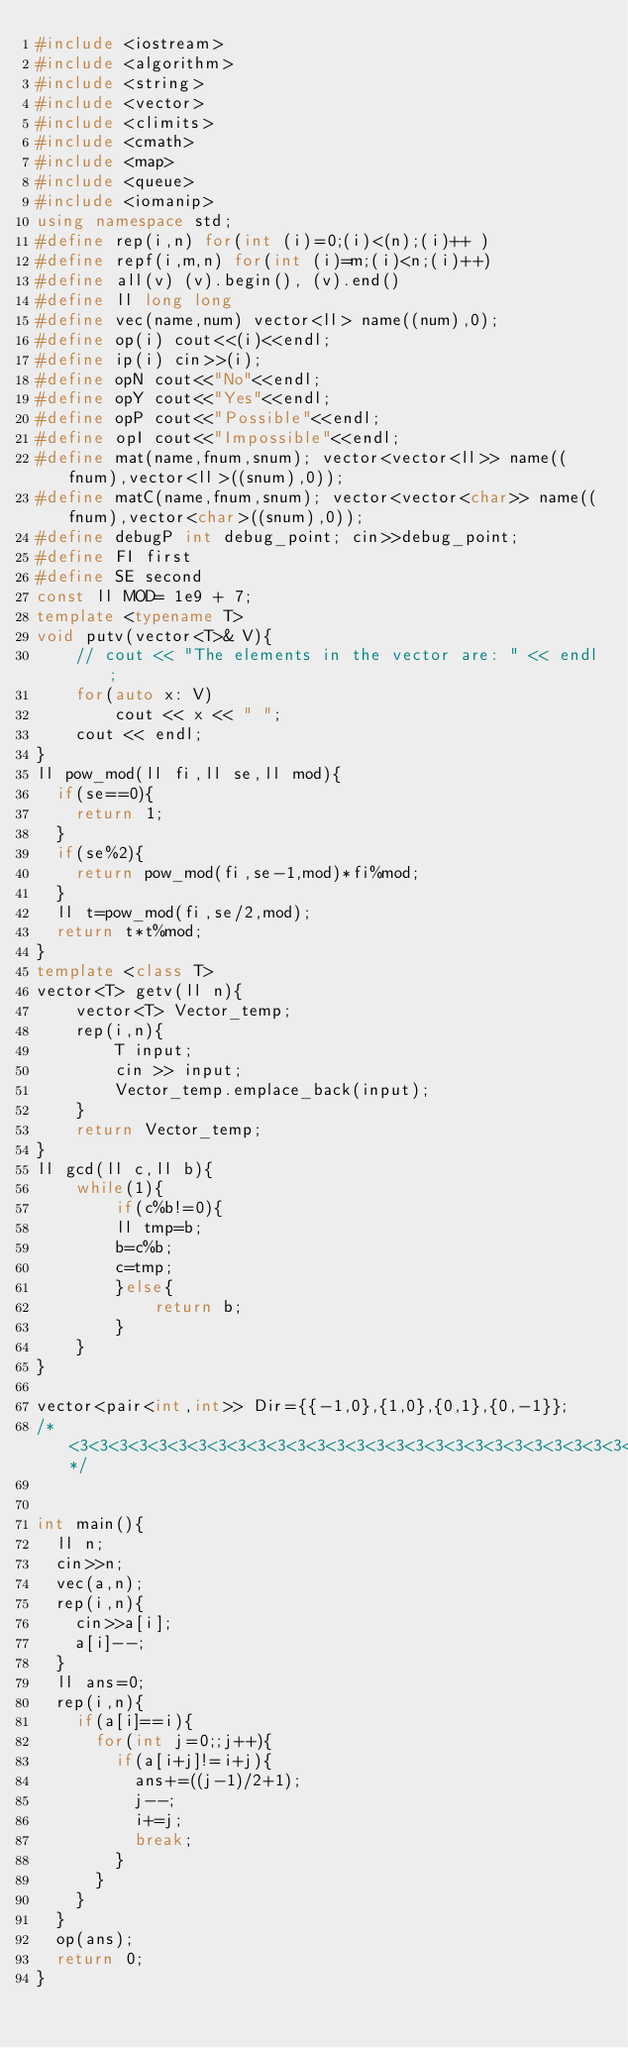<code> <loc_0><loc_0><loc_500><loc_500><_C++_>#include <iostream>
#include <algorithm>
#include <string>
#include <vector>
#include <climits>
#include <cmath>
#include <map>
#include <queue>
#include <iomanip>
using namespace std;
#define rep(i,n) for(int (i)=0;(i)<(n);(i)++ )
#define repf(i,m,n) for(int (i)=m;(i)<n;(i)++)
#define all(v) (v).begin(), (v).end()
#define ll long long
#define vec(name,num) vector<ll> name((num),0);
#define op(i) cout<<(i)<<endl;
#define ip(i) cin>>(i);
#define opN cout<<"No"<<endl;
#define opY cout<<"Yes"<<endl;
#define opP cout<<"Possible"<<endl;
#define opI cout<<"Impossible"<<endl;
#define mat(name,fnum,snum); vector<vector<ll>> name((fnum),vector<ll>((snum),0));
#define matC(name,fnum,snum); vector<vector<char>> name((fnum),vector<char>((snum),0));
#define debugP int debug_point; cin>>debug_point;
#define FI first
#define SE second
const ll MOD= 1e9 + 7;
template <typename T>
void putv(vector<T>& V){
	// cout << "The elements in the vector are: " << endl;
	for(auto x: V)
		cout << x << " ";
	cout << endl;
}
ll pow_mod(ll fi,ll se,ll mod){
  if(se==0){
    return 1;
  }
  if(se%2){
    return pow_mod(fi,se-1,mod)*fi%mod;
  }
  ll t=pow_mod(fi,se/2,mod);
  return t*t%mod;
}
template <class T>
vector<T> getv(ll n){
	vector<T> Vector_temp;
	rep(i,n){
		T input;
		cin >> input;
		Vector_temp.emplace_back(input);
	}
	return Vector_temp;
}
ll gcd(ll c,ll b){
    while(1){
        if(c%b!=0){
        ll tmp=b;
        b=c%b;
        c=tmp;
        }else{
            return b;
        }
    }
}

vector<pair<int,int>> Dir={{-1,0},{1,0},{0,1},{0,-1}};
/* <3<3<3<3<3<3<3<3<3<3<3<3<3<3<3<3<3<3<3<3<3<3<3<3<3<3<3<3<3<3<3<3*/


int main(){
  ll n;
  cin>>n;
  vec(a,n);
  rep(i,n){
    cin>>a[i];
    a[i]--;
  }
  ll ans=0;
  rep(i,n){
    if(a[i]==i){
      for(int j=0;;j++){
        if(a[i+j]!=i+j){
          ans+=((j-1)/2+1);
          j--;
          i+=j;
          break;
        }
      }
    }
  }
  op(ans);
  return 0;
}</code> 